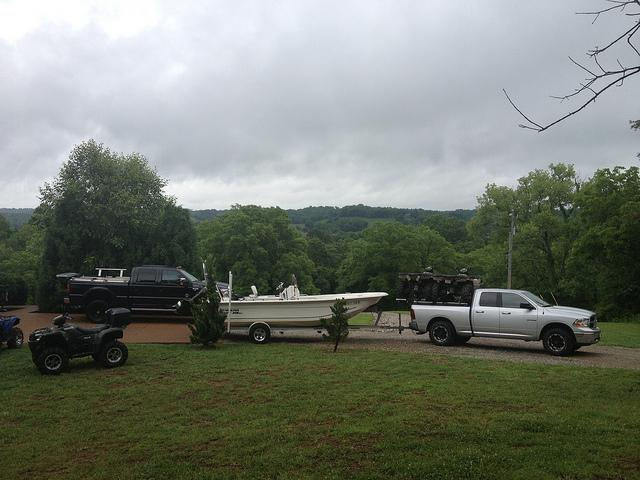What looks like it could happen any minute? Please explain your reasoning. rain. The skies are darkening, and the clouds are heavy and low as if a downpour will soon begin. 